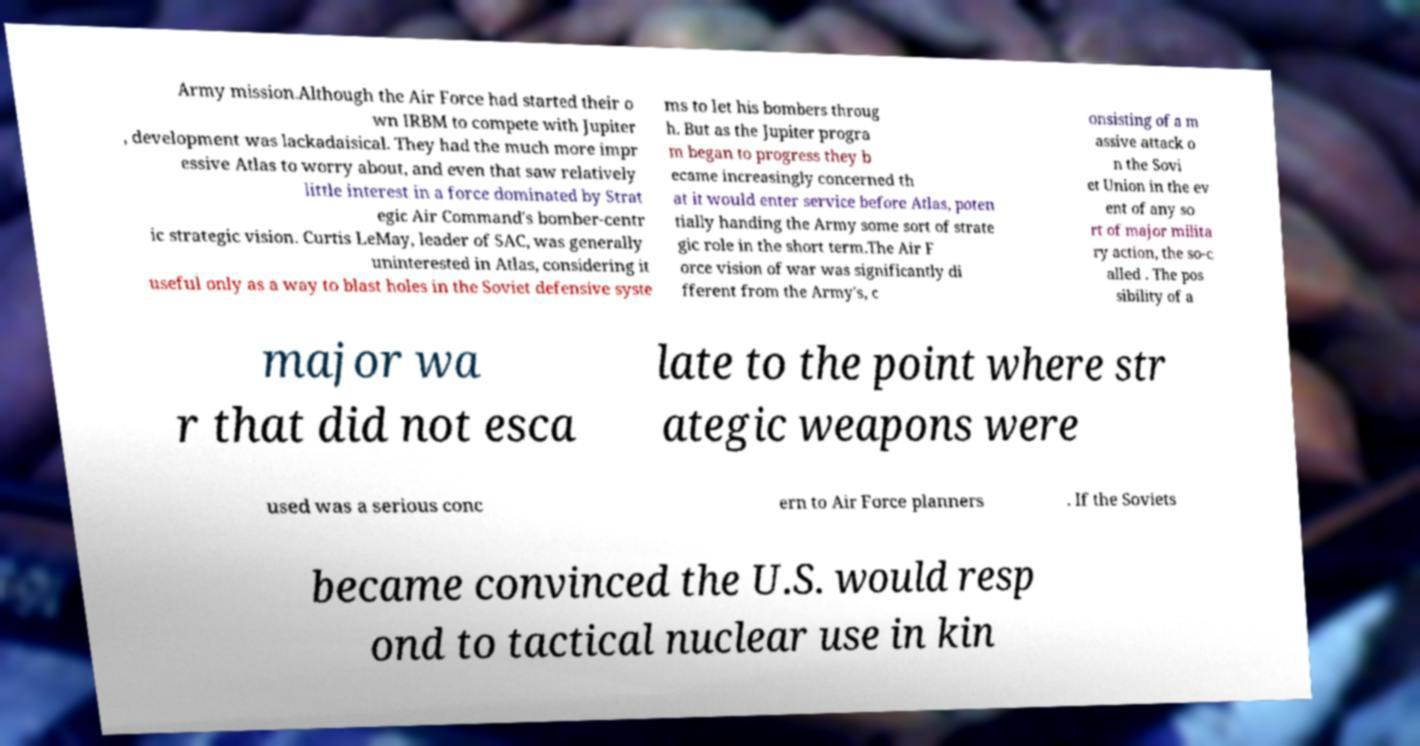Please read and relay the text visible in this image. What does it say? Army mission.Although the Air Force had started their o wn IRBM to compete with Jupiter , development was lackadaisical. They had the much more impr essive Atlas to worry about, and even that saw relatively little interest in a force dominated by Strat egic Air Command's bomber-centr ic strategic vision. Curtis LeMay, leader of SAC, was generally uninterested in Atlas, considering it useful only as a way to blast holes in the Soviet defensive syste ms to let his bombers throug h. But as the Jupiter progra m began to progress they b ecame increasingly concerned th at it would enter service before Atlas, poten tially handing the Army some sort of strate gic role in the short term.The Air F orce vision of war was significantly di fferent from the Army's, c onsisting of a m assive attack o n the Sovi et Union in the ev ent of any so rt of major milita ry action, the so-c alled . The pos sibility of a major wa r that did not esca late to the point where str ategic weapons were used was a serious conc ern to Air Force planners . If the Soviets became convinced the U.S. would resp ond to tactical nuclear use in kin 